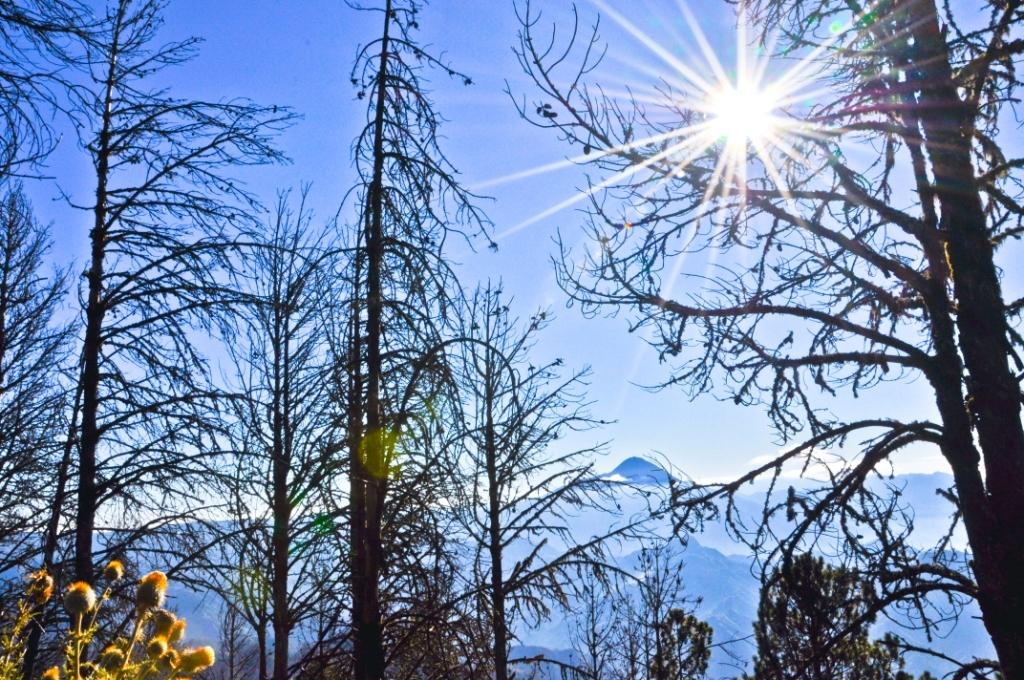What type of vegetation can be seen in the image? There are tree branches in the image. What geographical feature is present in the image? There is a mountain in the image. What type of plant is visible in the image? There is a flower in the image. What is visible in the sky in the image? The sky is visible in the image, and the sun is observable. How many visitors are present in the image? There are no visitors present in the image. What type of tool is being used to dig in the image? There is no tool or digging activity present in the image. 